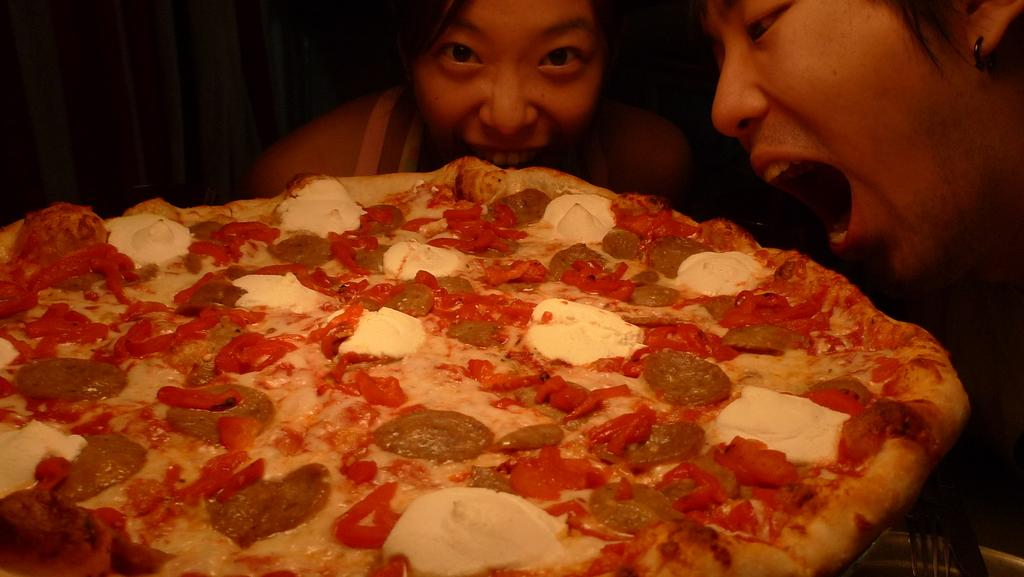How many people are in the image? There are two women in the image. What are the women doing in the image? The women are trying to eat pizza. Where is the pizza located in the image? The pizza is on a table. Can you describe the lighting in the image? The top left corner of the image appears to be dark. What type of orange is the sister using to brush her teeth in the image? There is no orange or sister present in the image, and no one is shown brushing their teeth. 